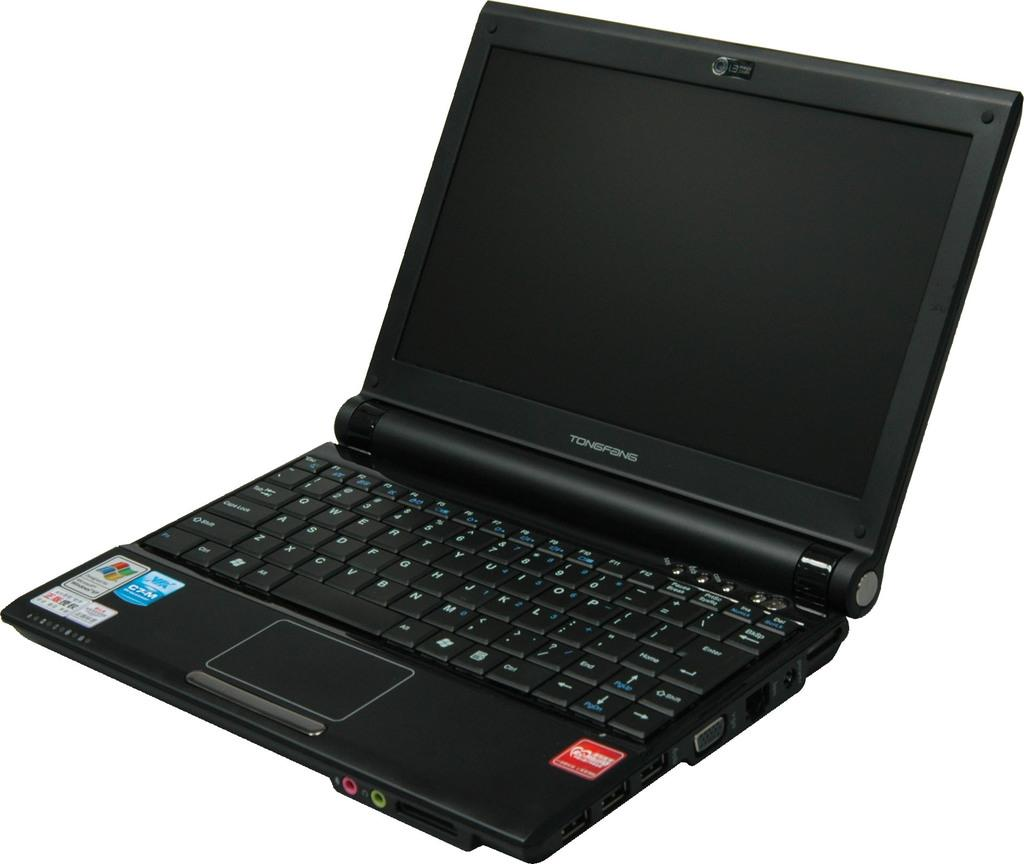What electronic device is visible in the image? There is a laptop in the image. What color is the laptop? The laptop is black in color. Is there any text or wording on the laptop? Yes, there is a word written on the laptop. How many stickers are on the laptop? There are 4 stickers on the laptop. What is the color of the background in the image? The background of the image is white. What type of pan is being used to cook on the laptop in the image? There is no pan or cooking activity present in the image; it only shows a laptop with a word and stickers. 